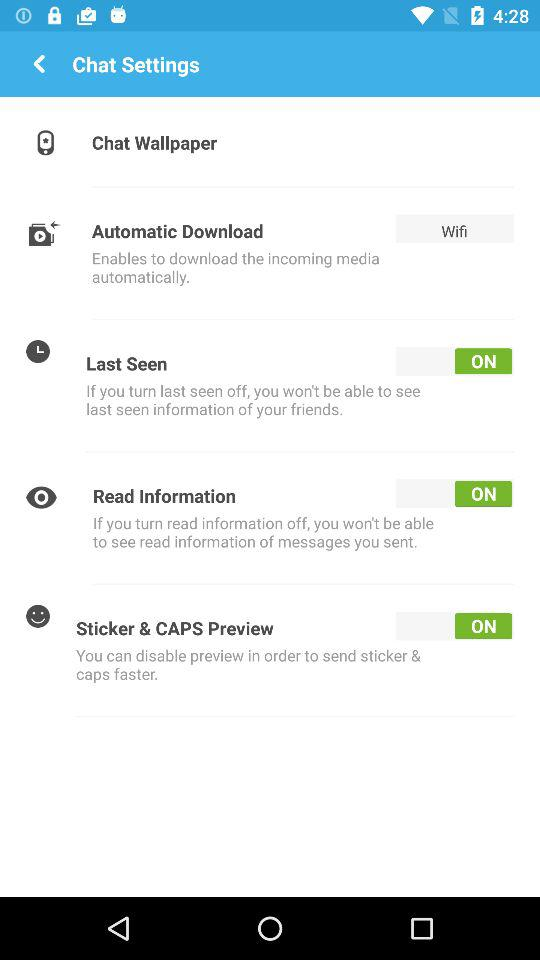What is the current status of the "Read Information"? The current status is "on". 